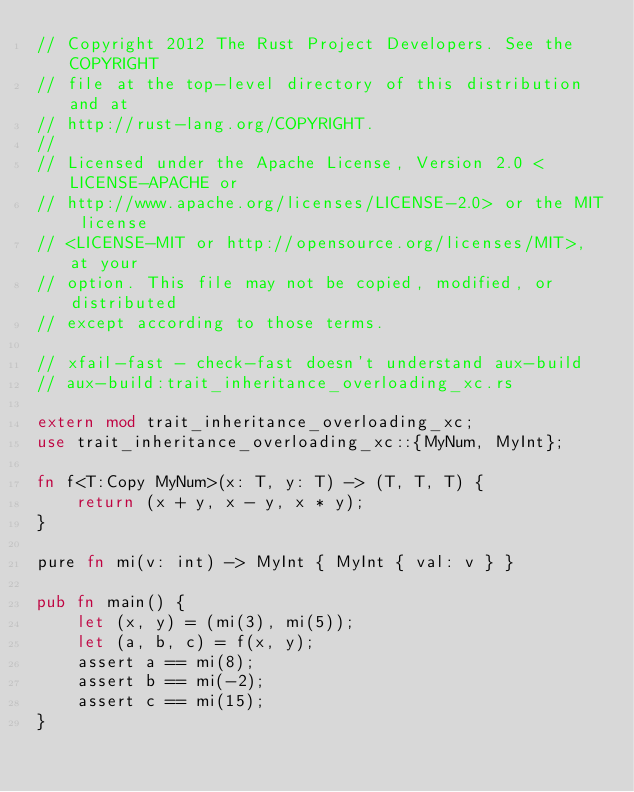<code> <loc_0><loc_0><loc_500><loc_500><_Rust_>// Copyright 2012 The Rust Project Developers. See the COPYRIGHT
// file at the top-level directory of this distribution and at
// http://rust-lang.org/COPYRIGHT.
//
// Licensed under the Apache License, Version 2.0 <LICENSE-APACHE or
// http://www.apache.org/licenses/LICENSE-2.0> or the MIT license
// <LICENSE-MIT or http://opensource.org/licenses/MIT>, at your
// option. This file may not be copied, modified, or distributed
// except according to those terms.

// xfail-fast - check-fast doesn't understand aux-build
// aux-build:trait_inheritance_overloading_xc.rs

extern mod trait_inheritance_overloading_xc;
use trait_inheritance_overloading_xc::{MyNum, MyInt};

fn f<T:Copy MyNum>(x: T, y: T) -> (T, T, T) {
    return (x + y, x - y, x * y);
}

pure fn mi(v: int) -> MyInt { MyInt { val: v } }

pub fn main() {
    let (x, y) = (mi(3), mi(5));
    let (a, b, c) = f(x, y);
    assert a == mi(8);
    assert b == mi(-2);
    assert c == mi(15);
}

</code> 